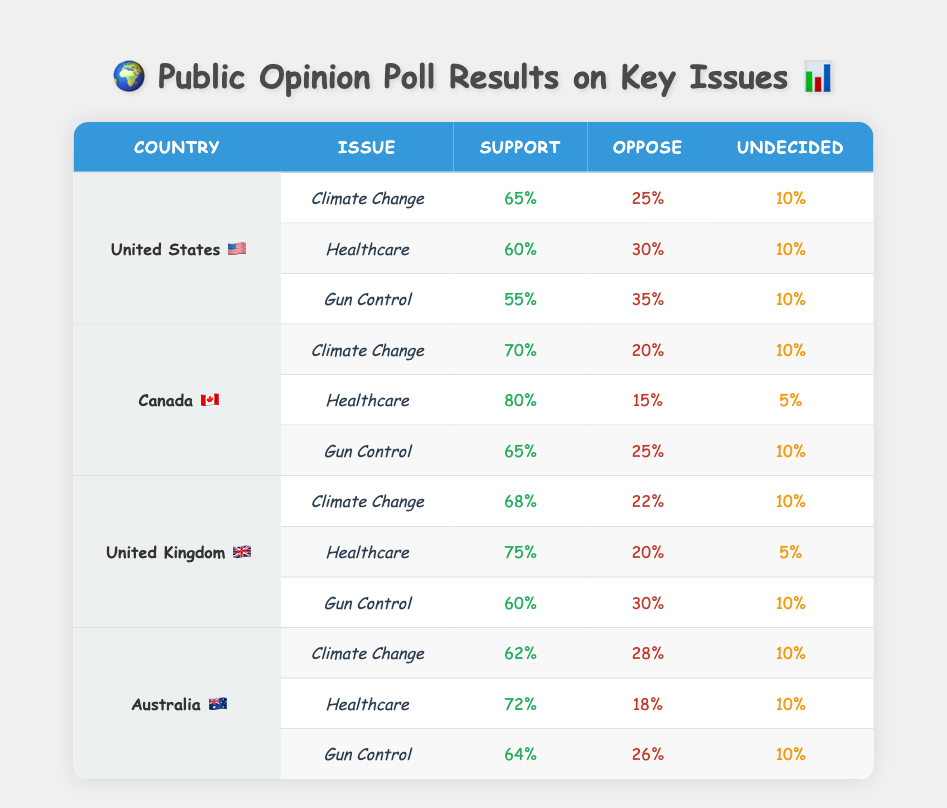What percentage of people in Canada support Climate Change? The table shows that in Canada, for the Climate Change issue, the Support percentage is 70%.
Answer: 70% Which country has the highest support for Healthcare? When looking at the Healthcare issue, Canada has a Support percentage of 80%, which is the highest among all the countries listed.
Answer: Canada What is the average percentage of support for Gun Control across all the countries? To find the average, we add the support percentages for Gun Control: 55% (US) + 65% (Canada) + 60% (UK) + 64% (Australia) = 244%. Then, we divide by the number of countries, which is 4. 244% / 4 = 61%.
Answer: 61% Is the support for Climate Change in Australia greater than the support for Climate Change in the United Kingdom? In Australia, the support for Climate Change is 62%, while in the United Kingdom, it is 68%. Since 62% is less than 68%, the statement is false.
Answer: No What is the percentage of people undecided about Healthcare in the United States compared to the United Kingdom? In the United States, the Undecided percentage for Healthcare is 10%, and in the United Kingdom, it is 5%. So, the US has a higher percentage of undecided individuals.
Answer: 10% in US vs 5% in UK Which issue has the highest opposition percentage in Canada? In Canada, the issue with the highest Opposition percentage is Healthcare, which is 15%.
Answer: Healthcare How many percentage points higher is the support for Climate Change in Canada compared to the United States? The Support for Climate Change in Canada is 70%, and in the United States, it is 65%. To find the difference, we subtract: 70% - 65% = 5%.
Answer: 5% Is the opposition to Gun Control in Australia higher than in the United Kingdom? Australia has an Opposition percentage of 26% for Gun Control, while the United Kingdom has 30%. Since 26% is less than 30%, the statement is false.
Answer: No 